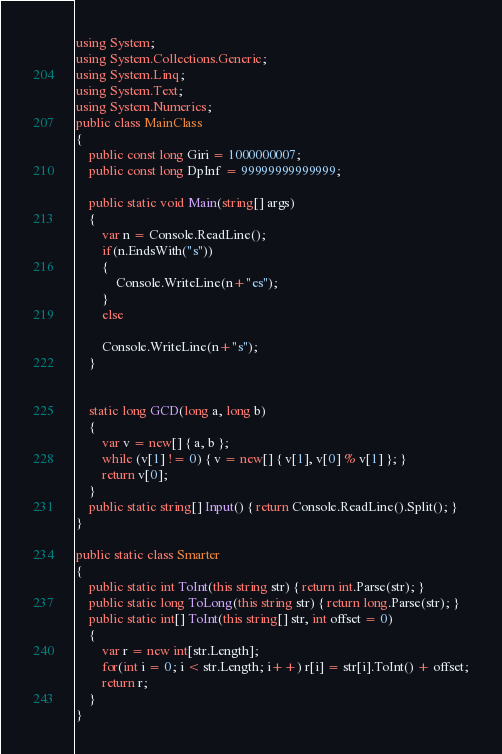<code> <loc_0><loc_0><loc_500><loc_500><_C#_>using System;
using System.Collections.Generic;
using System.Linq;
using System.Text;
using System.Numerics;
public class MainClass
{
	public const long Giri = 1000000007;
	public const long DpInf = 99999999999999;
	
	public static void Main(string[] args)
	{
		var n = Console.ReadLine();
		if(n.EndsWith("s"))
		{
			Console.WriteLine(n+"es");
		}
		else
		
		Console.WriteLine(n+"s");
	}

	
	static long GCD(long a, long b)
	{
		var v = new[] { a, b };
		while (v[1] != 0) { v = new[] { v[1], v[0] % v[1] }; }
		return v[0];
	}
	public static string[] Input() { return Console.ReadLine().Split(); }
}

public static class Smarter
{
	public static int ToInt(this string str) { return int.Parse(str); }
	public static long ToLong(this string str) { return long.Parse(str); }
	public static int[] ToInt(this string[] str, int offset = 0)
	{
		var r = new int[str.Length];
		for(int i = 0; i < str.Length; i++) r[i] = str[i].ToInt() + offset;
		return r;
	}
}
</code> 